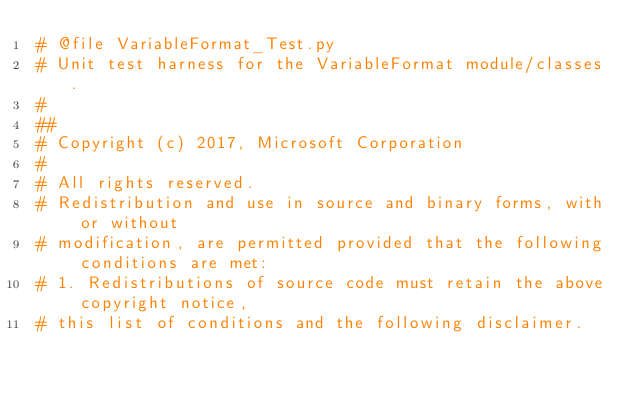Convert code to text. <code><loc_0><loc_0><loc_500><loc_500><_Python_># @file VariableFormat_Test.py
# Unit test harness for the VariableFormat module/classes.
#
##
# Copyright (c) 2017, Microsoft Corporation
#
# All rights reserved.
# Redistribution and use in source and binary forms, with or without
# modification, are permitted provided that the following conditions are met:
# 1. Redistributions of source code must retain the above copyright notice,
# this list of conditions and the following disclaimer.</code> 